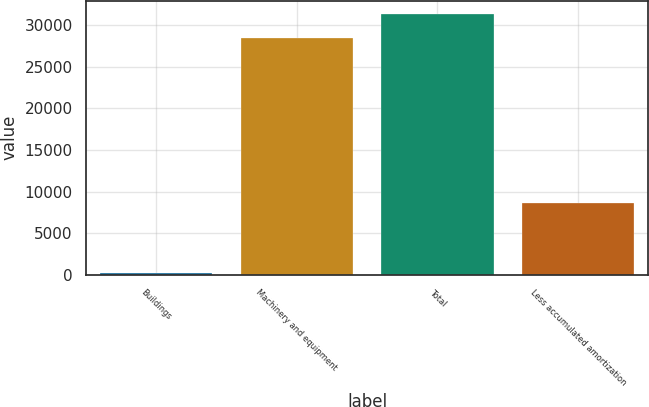Convert chart to OTSL. <chart><loc_0><loc_0><loc_500><loc_500><bar_chart><fcel>Buildings<fcel>Machinery and equipment<fcel>Total<fcel>Less accumulated amortization<nl><fcel>250<fcel>28526<fcel>31378.6<fcel>8676<nl></chart> 